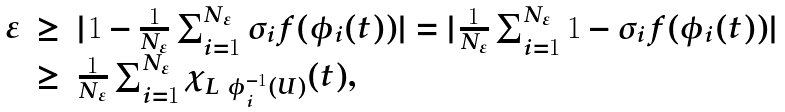<formula> <loc_0><loc_0><loc_500><loc_500>\begin{array} { l c l } \varepsilon & \geq & | 1 - \frac { 1 } { N _ { \varepsilon } } \sum _ { i = 1 } ^ { N _ { \varepsilon } } \sigma _ { i } f ( \phi _ { i } ( t ) ) | = | \frac { 1 } { N _ { \varepsilon } } \sum _ { i = 1 } ^ { N _ { \varepsilon } } 1 - \sigma _ { i } f ( \phi _ { i } ( t ) ) | \\ & \geq & \frac { 1 } { N _ { \varepsilon } } \sum _ { i = 1 } ^ { N _ { \varepsilon } } \chi _ { L \ \phi _ { i } ^ { - 1 } ( U ) } ( t ) , \end{array}</formula> 